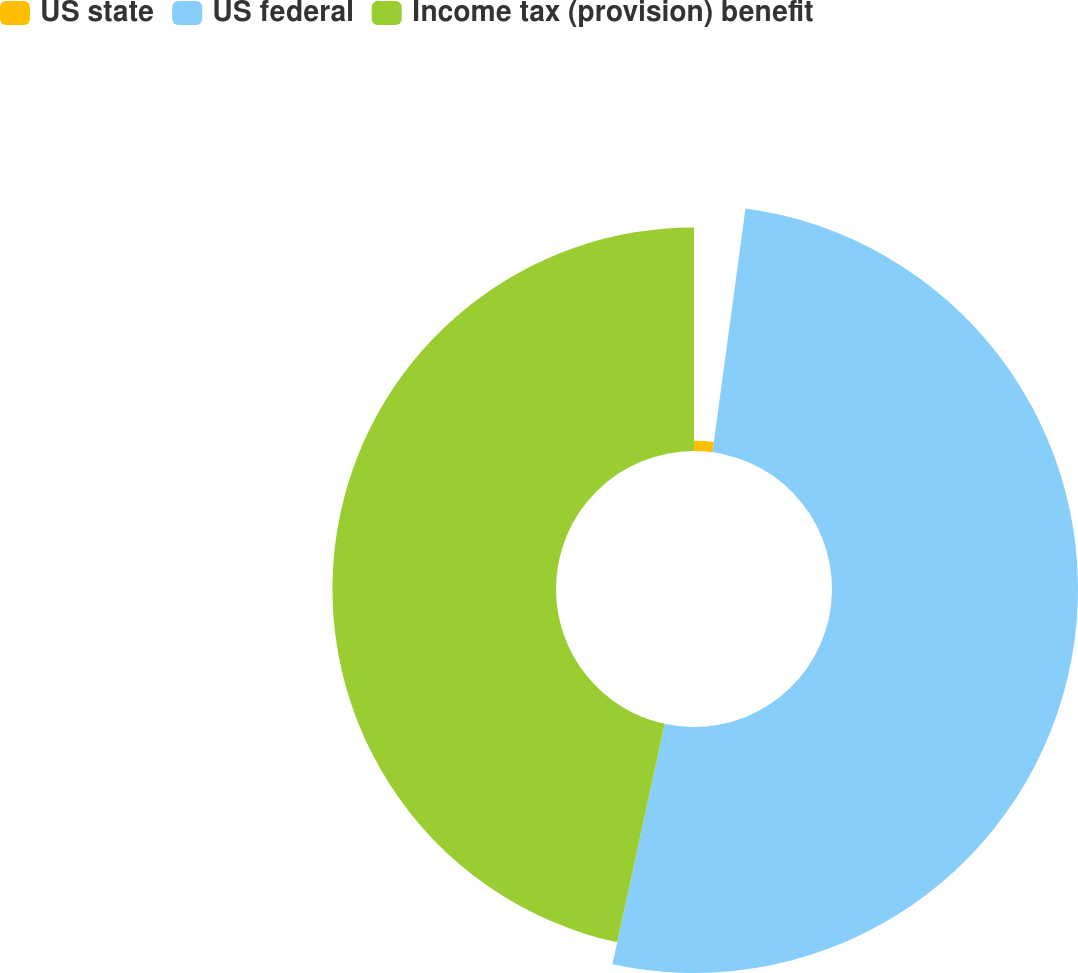Convert chart to OTSL. <chart><loc_0><loc_0><loc_500><loc_500><pie_chart><fcel>US state<fcel>US federal<fcel>Income tax (provision) benefit<nl><fcel>2.14%<fcel>51.27%<fcel>46.6%<nl></chart> 